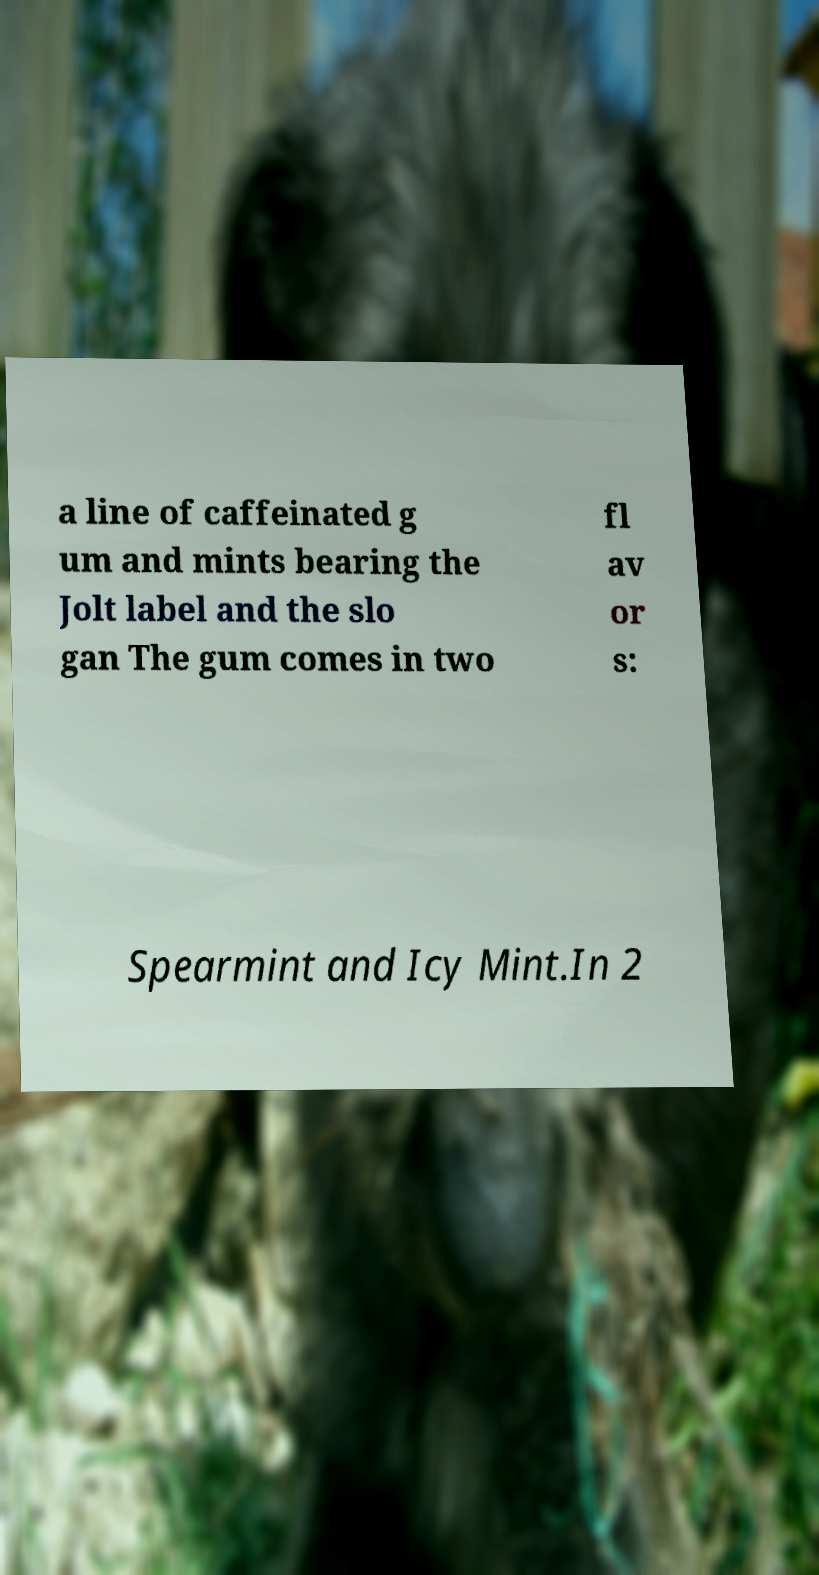Can you read and provide the text displayed in the image?This photo seems to have some interesting text. Can you extract and type it out for me? a line of caffeinated g um and mints bearing the Jolt label and the slo gan The gum comes in two fl av or s: Spearmint and Icy Mint.In 2 